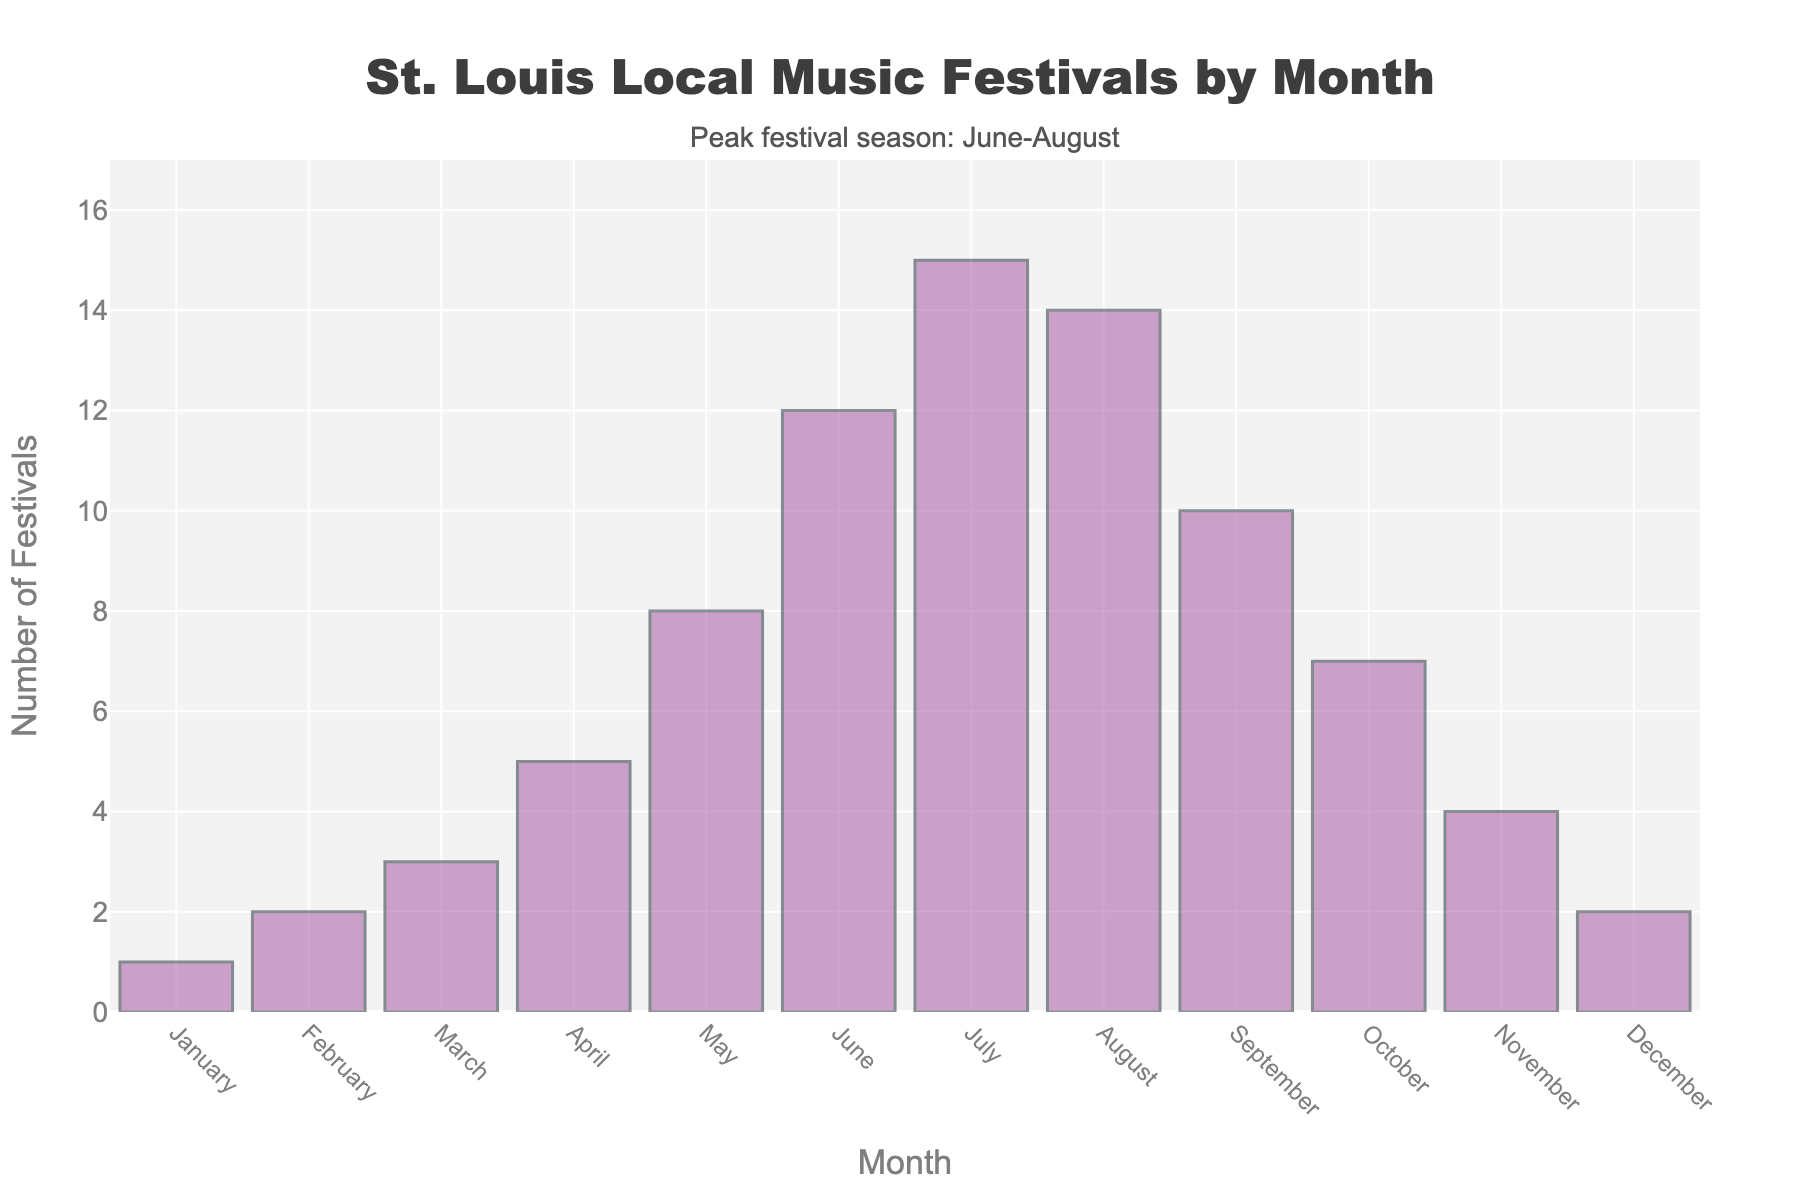What's the month with the highest number of music festivals? The bar representing July is the tallest among all months, indicating the highest number of music festivals.
Answer: July Which months have less than 5 festivals? From the figure, the bar heights for January, February, March, November, and December are all below the 5-mark on the y-axis.
Answer: January, February, March, November, December What is the total number of festivals in June, July, and August? The bars for June, July, and August show 12, 15, and 14 festivals respectively. Summing these gives 12 + 15 + 14.
Answer: 41 In which month does the number of festivals decrease compared to the previous month? Comparing the bar heights from month to month, the height of the bars decreases from July to August.
Answer: August What's the average number of festivals per month in the 3 peak months (June, July, August)? First, sum the festivals in June (12), July (15), and August (14) which is 12 + 15 + 14 = 41. Then, divide the sum by 3 (the number of months).
Answer: 13.67 Which month has exactly double the number of festivals as February? February has 2 festivals. Scanning the figure, December has 4 festivals which is double that of February.
Answer: December How many more festivals are there in April compared to March? The bar for April shows 5 festivals, and for March, it shows 3 festivals. The difference is 5 - 3.
Answer: 2 Identify the range of the number of festivals across all months. The smallest number of festivals is 1 (January) and the largest is 15 (July). Therefore, the range is 15 - 1.
Answer: 14 What's the combined total of festivals for the first quarter (January, February, March) and the last quarter (October, November, December)? Summing festivals for Q1: 1 + 2 + 3 = 6 and Q4: 7 + 4 + 2 = 13. The combined total is 6 + 13.
Answer: 19 If you were to organize an additional festival in each of the months with the lowest attendance, how many festivals would there be in total? The months with the lowest attendance are January (1 festival). Adding 1 festival to each (i.e., 1 + 1 = 2) would change the yearly total. Current total: 1 + 2 + 3 + 5 + 8 + 12 + 15 + 14 + 10 + 7 + 4 + 2 = 83. So 83 + 1 = 84.
Answer: 84 